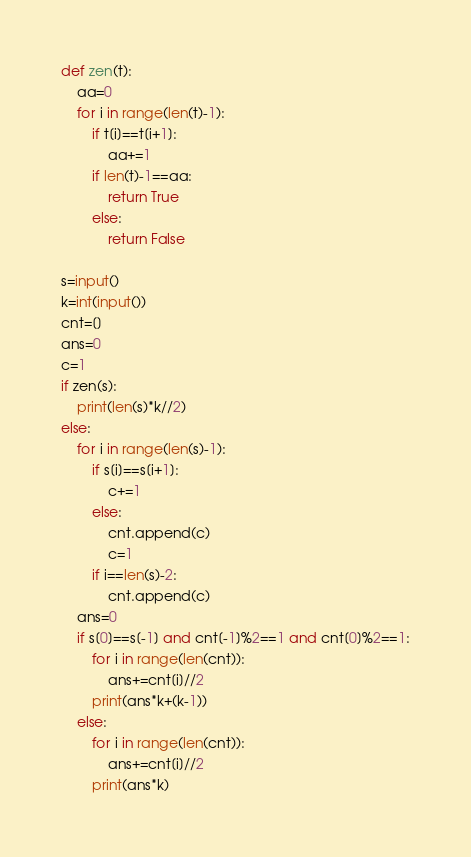<code> <loc_0><loc_0><loc_500><loc_500><_Python_>def zen(t):
    aa=0
    for i in range(len(t)-1):
        if t[i]==t[i+1]:
            aa+=1
        if len(t)-1==aa:
            return True
        else:
            return False

s=input()
k=int(input())
cnt=[]
ans=0
c=1
if zen(s):
    print(len(s)*k//2)
else:
    for i in range(len(s)-1):
        if s[i]==s[i+1]:
            c+=1
        else:
            cnt.append(c)
            c=1
        if i==len(s)-2:
            cnt.append(c)
    ans=0
    if s[0]==s[-1] and cnt[-1]%2==1 and cnt[0]%2==1:
        for i in range(len(cnt)):
            ans+=cnt[i]//2
        print(ans*k+(k-1))
    else:
        for i in range(len(cnt)):
            ans+=cnt[i]//2
        print(ans*k)</code> 